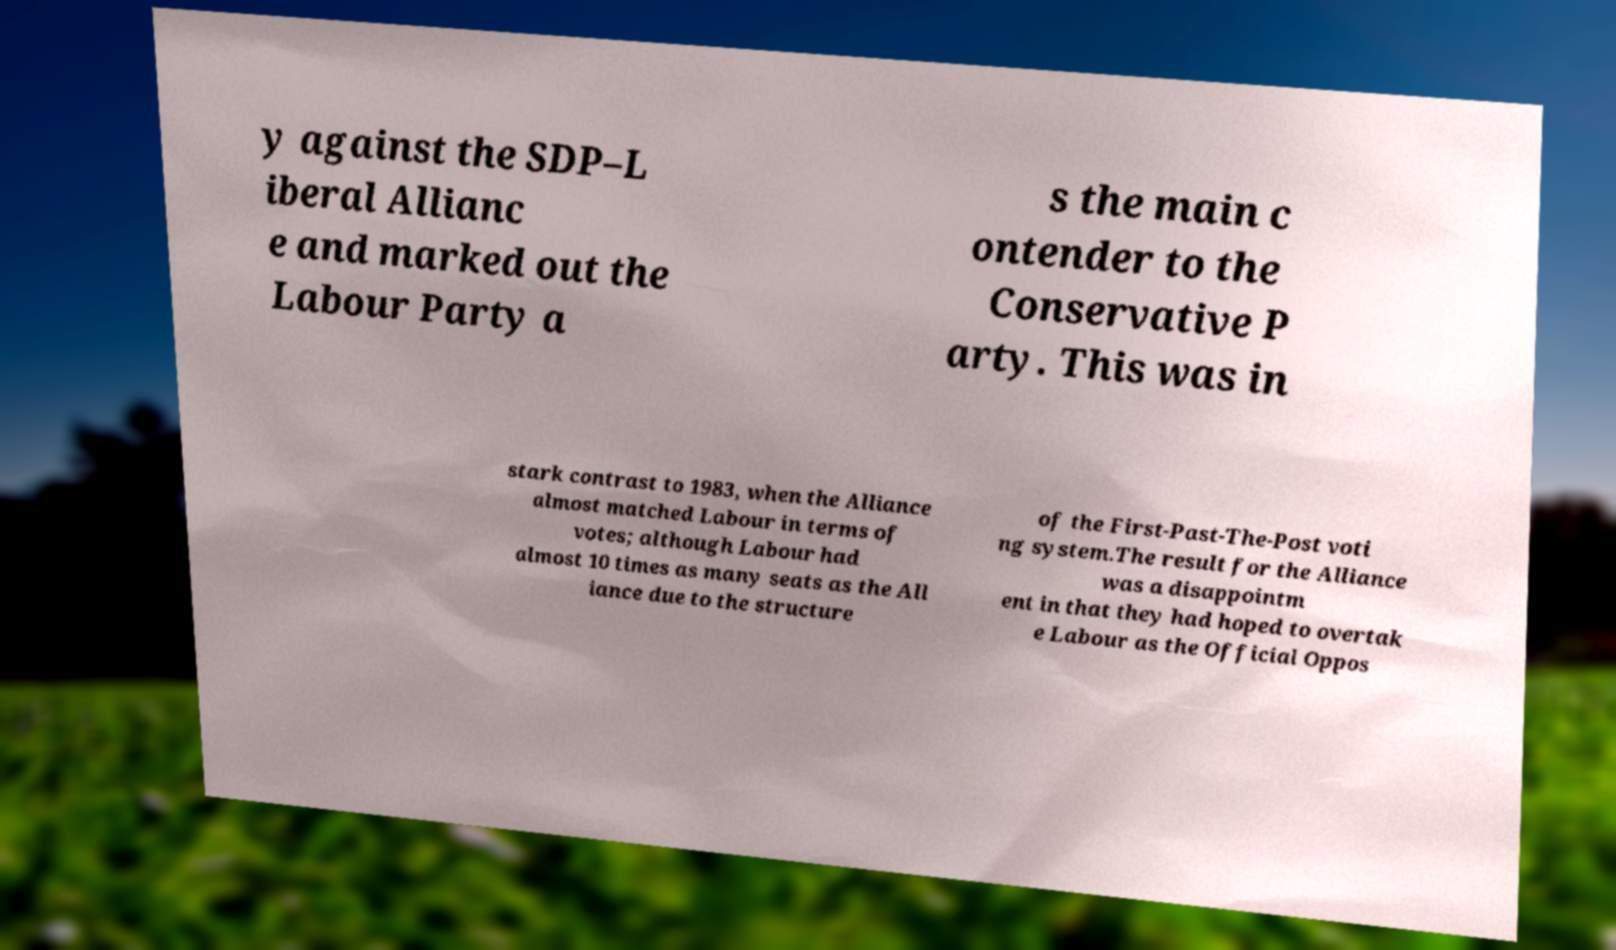Can you read and provide the text displayed in the image?This photo seems to have some interesting text. Can you extract and type it out for me? y against the SDP–L iberal Allianc e and marked out the Labour Party a s the main c ontender to the Conservative P arty. This was in stark contrast to 1983, when the Alliance almost matched Labour in terms of votes; although Labour had almost 10 times as many seats as the All iance due to the structure of the First-Past-The-Post voti ng system.The result for the Alliance was a disappointm ent in that they had hoped to overtak e Labour as the Official Oppos 